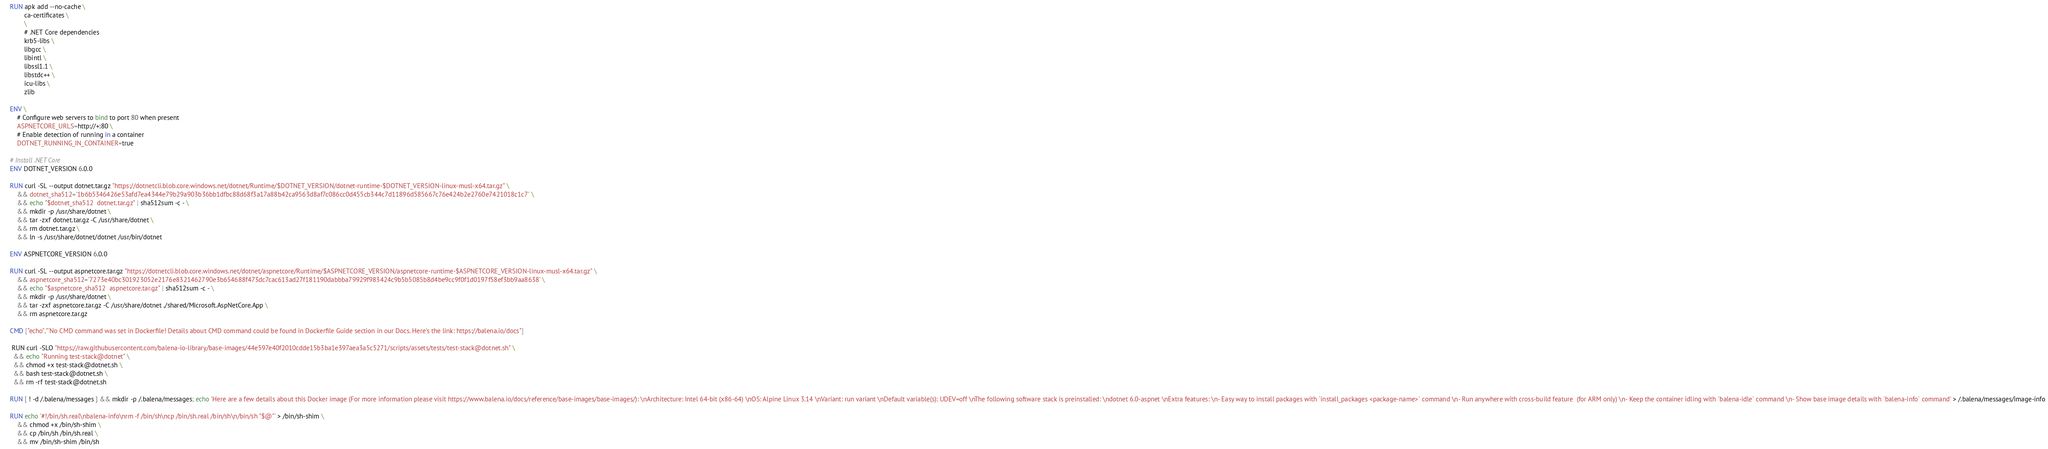Convert code to text. <code><loc_0><loc_0><loc_500><loc_500><_Dockerfile_>
RUN apk add --no-cache \
        ca-certificates \
        \
        # .NET Core dependencies
        krb5-libs \
        libgcc \
        libintl \
        libssl1.1 \
        libstdc++ \
        icu-libs \
        zlib

ENV \
    # Configure web servers to bind to port 80 when present
    ASPNETCORE_URLS=http://+:80 \
    # Enable detection of running in a container
    DOTNET_RUNNING_IN_CONTAINER=true

# Install .NET Core
ENV DOTNET_VERSION 6.0.0

RUN curl -SL --output dotnet.tar.gz "https://dotnetcli.blob.core.windows.net/dotnet/Runtime/$DOTNET_VERSION/dotnet-runtime-$DOTNET_VERSION-linux-musl-x64.tar.gz" \
    && dotnet_sha512='1b6b5346426e53afd7ea4344e79b29a903b36bb1dfbc88d68f3a17a88b42ca9563d8af7c086cc0d455cb344c7d11896d585667c76e424b2e2760e7421018c1c7' \
    && echo "$dotnet_sha512  dotnet.tar.gz" | sha512sum -c - \
    && mkdir -p /usr/share/dotnet \
    && tar -zxf dotnet.tar.gz -C /usr/share/dotnet \
    && rm dotnet.tar.gz \
    && ln -s /usr/share/dotnet/dotnet /usr/bin/dotnet

ENV ASPNETCORE_VERSION 6.0.0

RUN curl -SL --output aspnetcore.tar.gz "https://dotnetcli.blob.core.windows.net/dotnet/aspnetcore/Runtime/$ASPNETCORE_VERSION/aspnetcore-runtime-$ASPNETCORE_VERSION-linux-musl-x64.tar.gz" \
    && aspnetcore_sha512='7273e40bc301923052e2176e8321462790e3b654688f473dc7cac613ad27f181190dabbba79929f983424c9b5b5085b8d4be9cc9f0f1d0197f58ef3bb9aa8638' \
    && echo "$aspnetcore_sha512  aspnetcore.tar.gz" | sha512sum -c - \
    && mkdir -p /usr/share/dotnet \
    && tar -zxf aspnetcore.tar.gz -C /usr/share/dotnet ./shared/Microsoft.AspNetCore.App \
    && rm aspnetcore.tar.gz

CMD ["echo","'No CMD command was set in Dockerfile! Details about CMD command could be found in Dockerfile Guide section in our Docs. Here's the link: https://balena.io/docs"]

 RUN curl -SLO "https://raw.githubusercontent.com/balena-io-library/base-images/44e597e40f2010cdde15b3ba1e397aea3a5c5271/scripts/assets/tests/test-stack@dotnet.sh" \
  && echo "Running test-stack@dotnet" \
  && chmod +x test-stack@dotnet.sh \
  && bash test-stack@dotnet.sh \
  && rm -rf test-stack@dotnet.sh 

RUN [ ! -d /.balena/messages ] && mkdir -p /.balena/messages; echo 'Here are a few details about this Docker image (For more information please visit https://www.balena.io/docs/reference/base-images/base-images/): \nArchitecture: Intel 64-bit (x86-64) \nOS: Alpine Linux 3.14 \nVariant: run variant \nDefault variable(s): UDEV=off \nThe following software stack is preinstalled: \ndotnet 6.0-aspnet \nExtra features: \n- Easy way to install packages with `install_packages <package-name>` command \n- Run anywhere with cross-build feature  (for ARM only) \n- Keep the container idling with `balena-idle` command \n- Show base image details with `balena-info` command' > /.balena/messages/image-info

RUN echo '#!/bin/sh.real\nbalena-info\nrm -f /bin/sh\ncp /bin/sh.real /bin/sh\n/bin/sh "$@"' > /bin/sh-shim \
	&& chmod +x /bin/sh-shim \
	&& cp /bin/sh /bin/sh.real \
	&& mv /bin/sh-shim /bin/sh</code> 